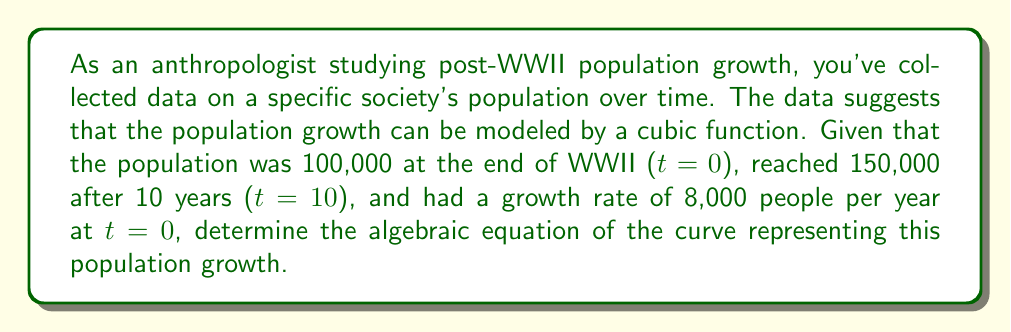Give your solution to this math problem. Let's approach this step-by-step:

1) We're looking for a cubic function of the form:
   $$P(t) = at^3 + bt^2 + ct + d$$
   where $P$ is the population and $t$ is the time in years since the end of WWII.

2) We know that at t=0, P=100,000. This gives us:
   $$100,000 = d$$

3) At t=10, P=150,000:
   $$150,000 = 1000a + 100b + 10c + 100,000$$
   $$50,000 = 1000a + 100b + 10c$$ ... (Equation 1)

4) The growth rate at t=0 is the derivative of P(t) at t=0:
   $$P'(t) = 3at^2 + 2bt + c$$
   $$P'(0) = c = 8,000$$

5) Now we have:
   $$P(t) = at^3 + bt^2 + 8,000t + 100,000$$

6) Differentiating again:
   $$P''(t) = 6at + 2b$$
   At t=0, this should be positive for increasing growth. Let's assume $b = 3a$ for simplicity.

7) Substituting back into Equation 1:
   $$50,000 = 1000a + 300a + 80,000$$
   $$-30,000 = 1300a$$
   $$a = -23.0769...$$

8) Therefore, $b = 3a = -69.2307...$

9) Our final equation is:
   $$P(t) = -23.0769t^3 - 69.2307t^2 + 8,000t + 100,000$$
Answer: $P(t) = -23.0769t^3 - 69.2307t^2 + 8,000t + 100,000$ 